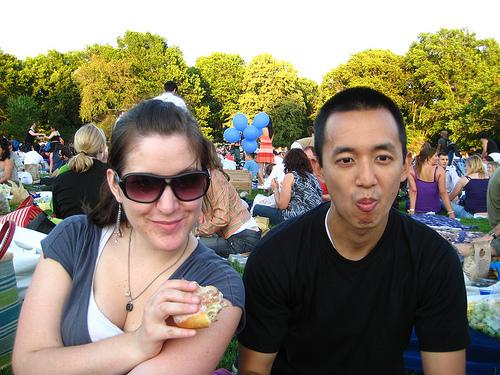What is the woman holding?
Be succinct. Sandwich. Who is eating the sandwich?
Concise answer only. Girl. These people are eating?
Short answer required. Yes. How many balloons are in this picture?
Answer briefly. 5. 